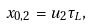<formula> <loc_0><loc_0><loc_500><loc_500>x _ { 0 , 2 } = u _ { 2 } \tau _ { L } ,</formula> 